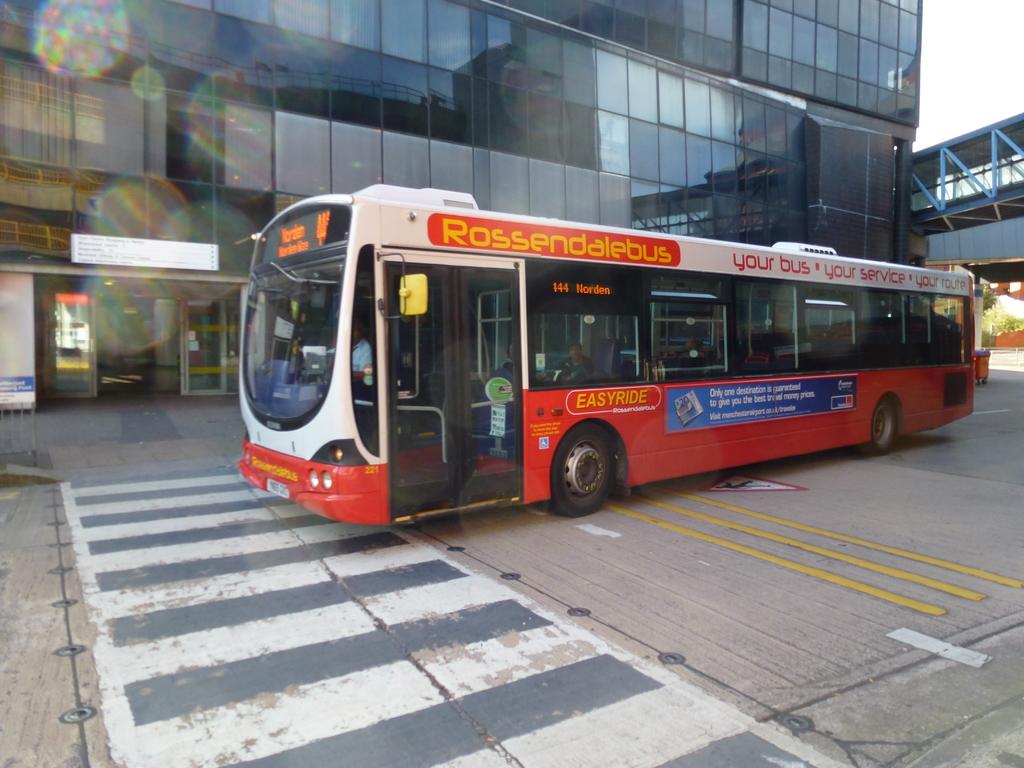What is the name of the bus?
Provide a succinct answer. Rossendalebus. 